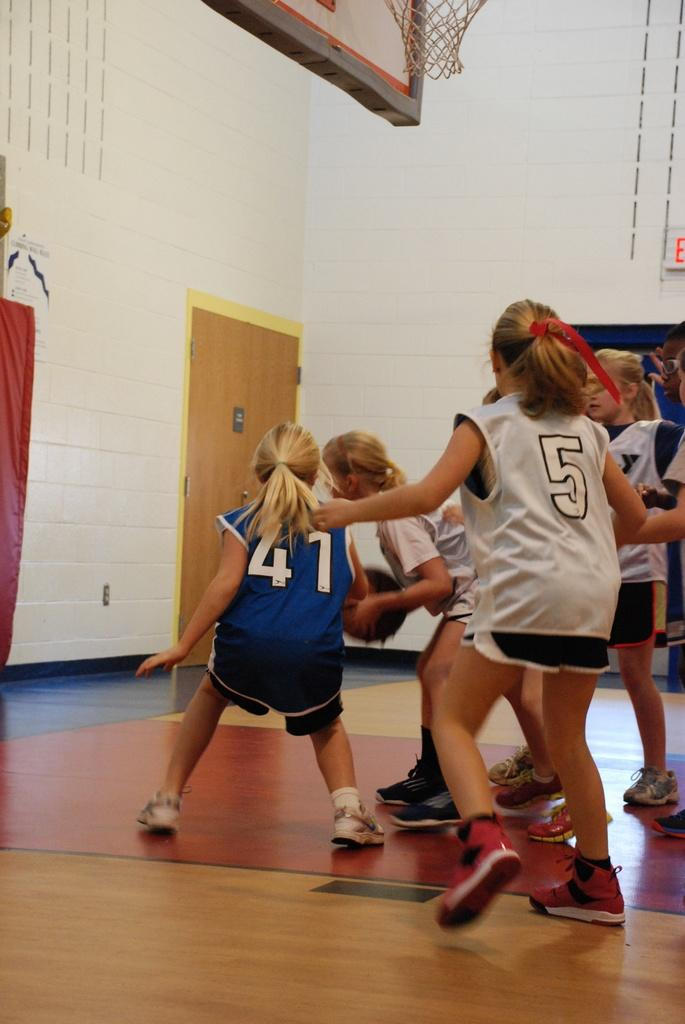Provide a one-sentence caption for the provided image. Girls playing basketball wearing number 41 and 5 jerseys. 